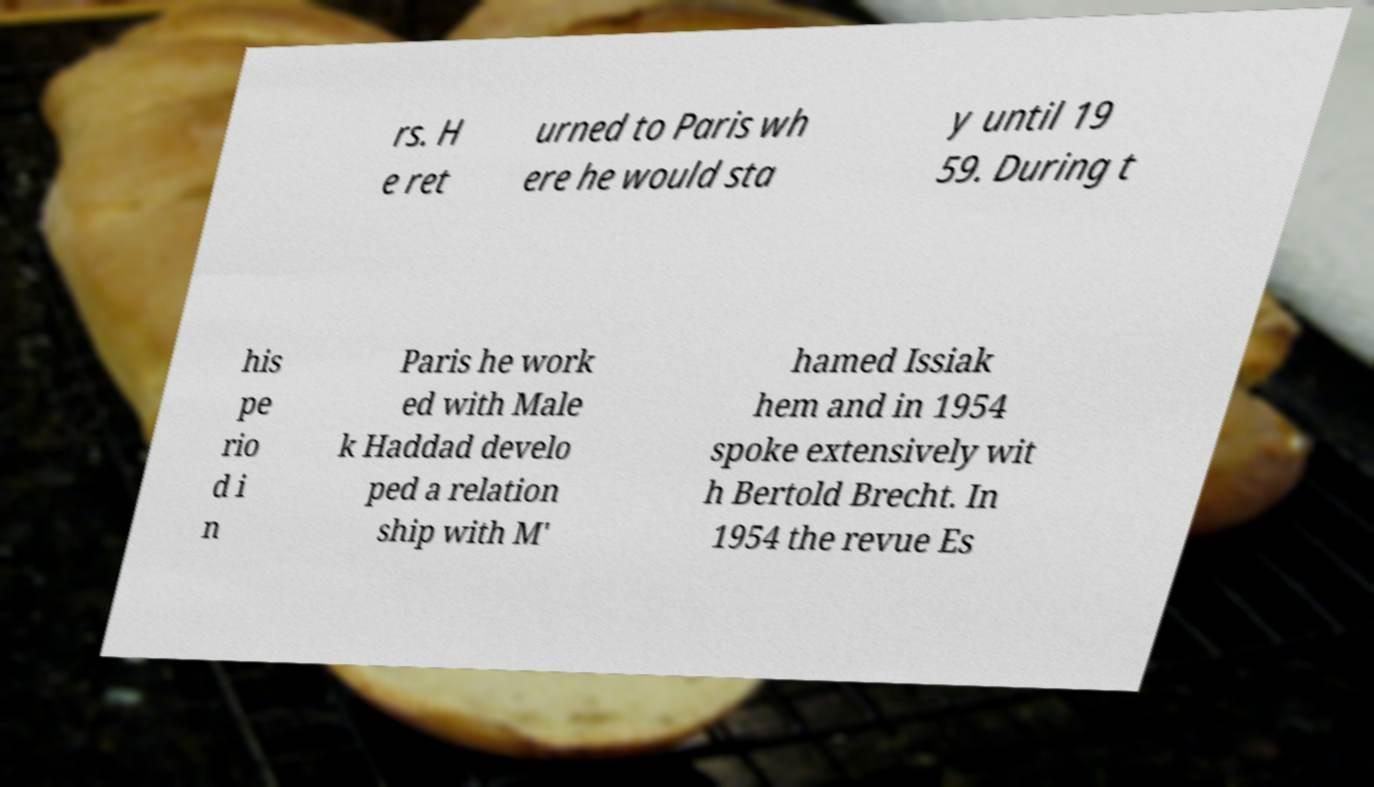I need the written content from this picture converted into text. Can you do that? rs. H e ret urned to Paris wh ere he would sta y until 19 59. During t his pe rio d i n Paris he work ed with Male k Haddad develo ped a relation ship with M' hamed Issiak hem and in 1954 spoke extensively wit h Bertold Brecht. In 1954 the revue Es 